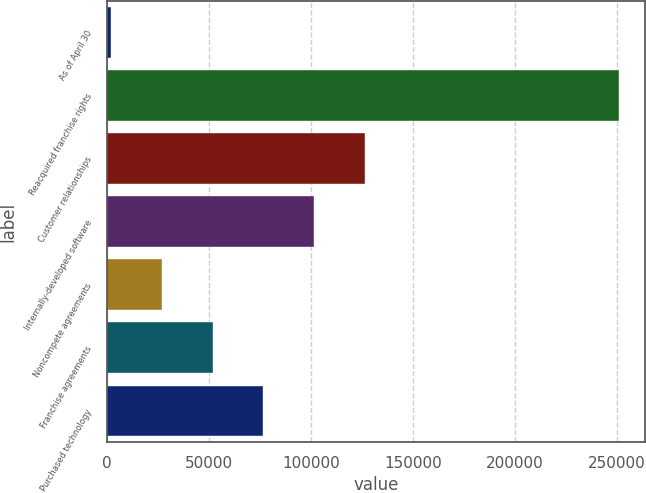Convert chart. <chart><loc_0><loc_0><loc_500><loc_500><bar_chart><fcel>As of April 30<fcel>Reacquired franchise rights<fcel>Customer relationships<fcel>Internally-developed software<fcel>Noncompete agreements<fcel>Franchise agreements<fcel>Purchased technology<nl><fcel>2016<fcel>251070<fcel>126543<fcel>101638<fcel>26921.4<fcel>51826.8<fcel>76732.2<nl></chart> 